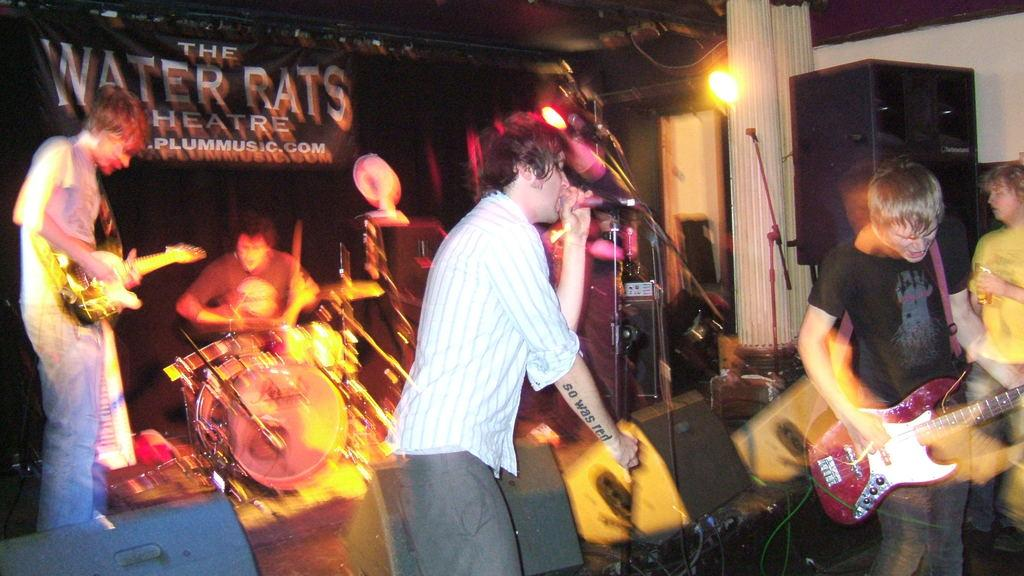What is happening in the image involving the group of people? The people in the image are playing musical instruments. Can you describe any objects related to the musical performance? Yes, there is a light and a loudspeaker in the image. What type of process is being carried out by the sister in the image? There is no sister present in the image, and no process is being carried out. 